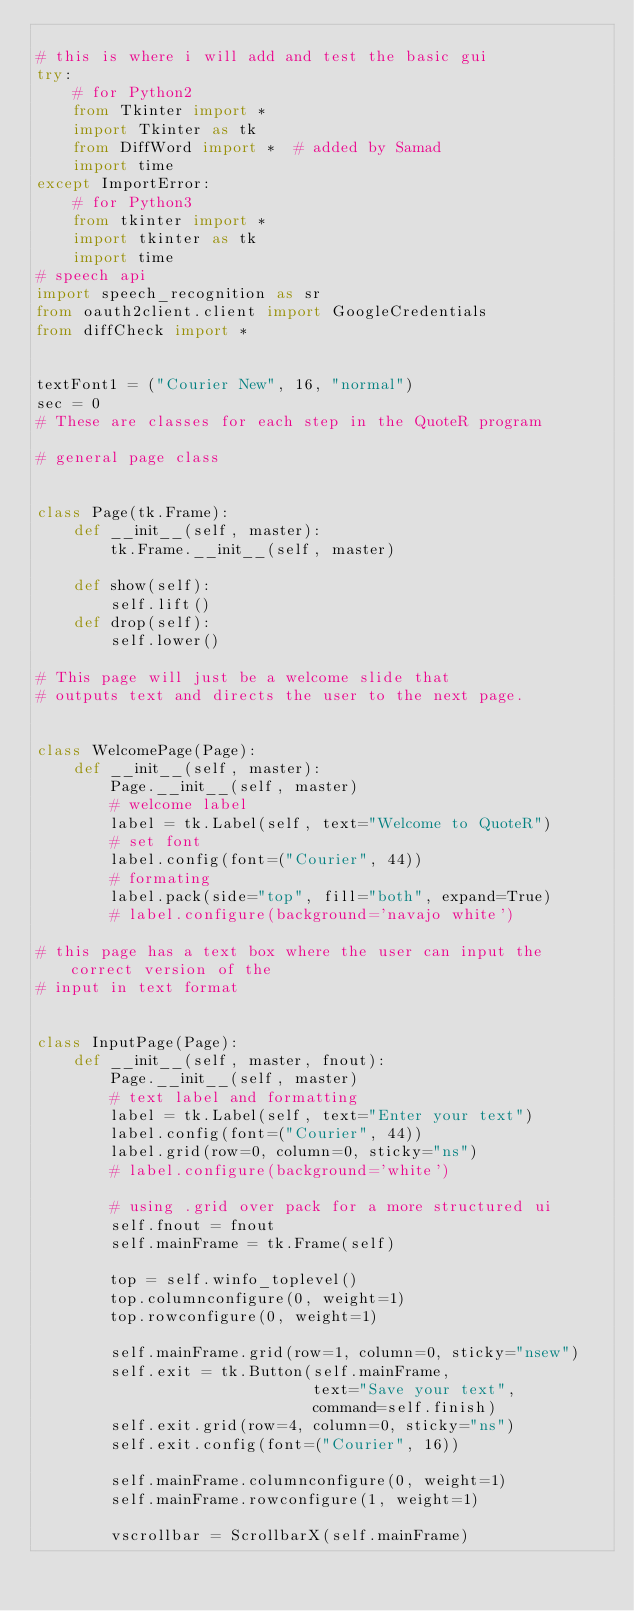<code> <loc_0><loc_0><loc_500><loc_500><_Python_>
# this is where i will add and test the basic gui
try:
    # for Python2
    from Tkinter import *
    import Tkinter as tk
    from DiffWord import *  # added by Samad
    import time
except ImportError:
    # for Python3
    from tkinter import *
    import tkinter as tk
    import time
# speech api
import speech_recognition as sr
from oauth2client.client import GoogleCredentials
from diffCheck import *


textFont1 = ("Courier New", 16, "normal")
sec = 0
# These are classes for each step in the QuoteR program

# general page class


class Page(tk.Frame):
    def __init__(self, master):
        tk.Frame.__init__(self, master)

    def show(self):
        self.lift()
    def drop(self):
        self.lower()

# This page will just be a welcome slide that
# outputs text and directs the user to the next page.


class WelcomePage(Page):
    def __init__(self, master):
        Page.__init__(self, master)
        # welcome label
        label = tk.Label(self, text="Welcome to QuoteR")
        # set font
        label.config(font=("Courier", 44))
        # formating
        label.pack(side="top", fill="both", expand=True)
        # label.configure(background='navajo white')

# this page has a text box where the user can input the correct version of the
# input in text format


class InputPage(Page):
    def __init__(self, master, fnout):
        Page.__init__(self, master)
        # text label and formatting
        label = tk.Label(self, text="Enter your text")
        label.config(font=("Courier", 44))
        label.grid(row=0, column=0, sticky="ns")
        # label.configure(background='white')

        # using .grid over pack for a more structured ui
        self.fnout = fnout
        self.mainFrame = tk.Frame(self)

        top = self.winfo_toplevel()
        top.columnconfigure(0, weight=1)
        top.rowconfigure(0, weight=1)

        self.mainFrame.grid(row=1, column=0, sticky="nsew")
        self.exit = tk.Button(self.mainFrame,
                              text="Save your text",
                              command=self.finish)
        self.exit.grid(row=4, column=0, sticky="ns")
        self.exit.config(font=("Courier", 16))

        self.mainFrame.columnconfigure(0, weight=1)
        self.mainFrame.rowconfigure(1, weight=1)

        vscrollbar = ScrollbarX(self.mainFrame)</code> 